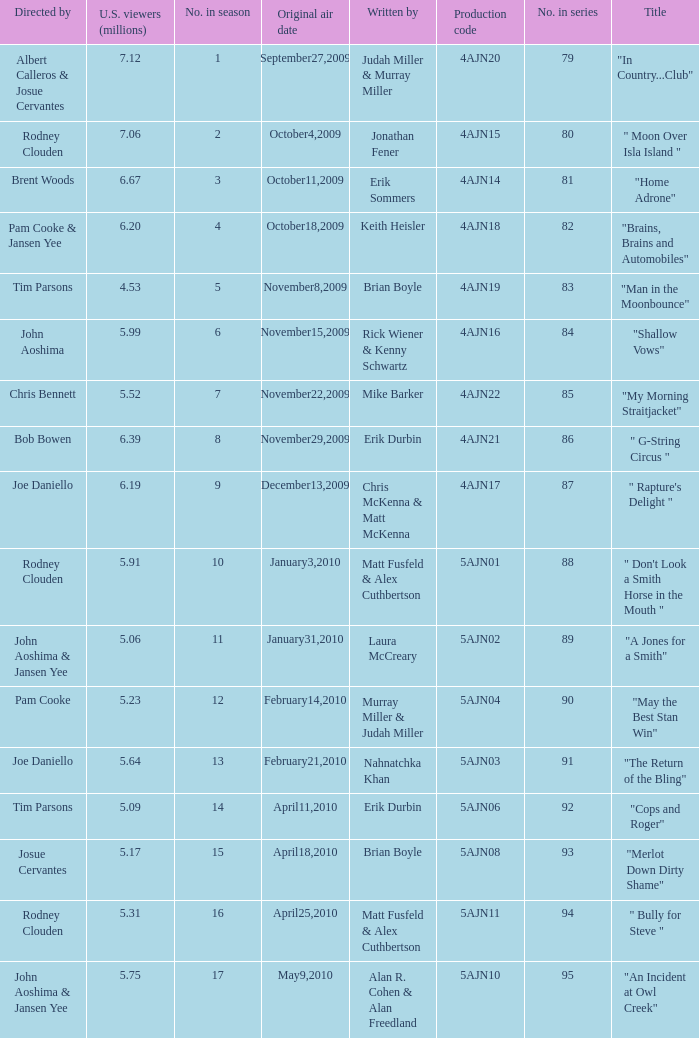Name who wrote the episode directed by  pam cooke & jansen yee Keith Heisler. 